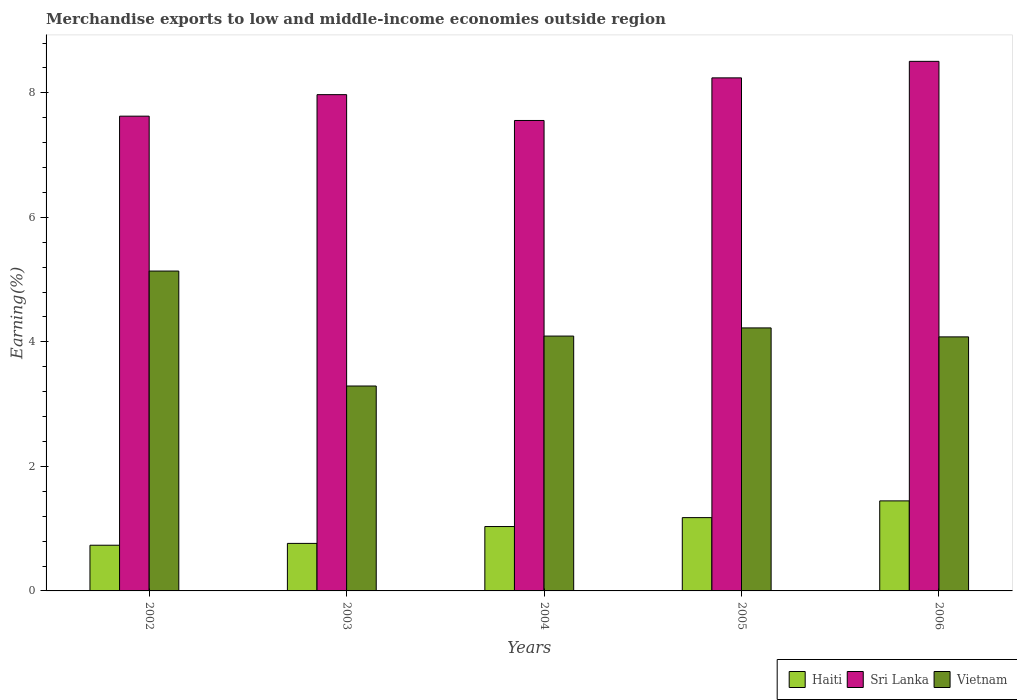Are the number of bars per tick equal to the number of legend labels?
Offer a very short reply. Yes. How many bars are there on the 1st tick from the right?
Your response must be concise. 3. In how many cases, is the number of bars for a given year not equal to the number of legend labels?
Your response must be concise. 0. What is the percentage of amount earned from merchandise exports in Sri Lanka in 2006?
Make the answer very short. 8.51. Across all years, what is the maximum percentage of amount earned from merchandise exports in Haiti?
Your answer should be very brief. 1.45. Across all years, what is the minimum percentage of amount earned from merchandise exports in Sri Lanka?
Provide a succinct answer. 7.56. In which year was the percentage of amount earned from merchandise exports in Vietnam maximum?
Make the answer very short. 2002. In which year was the percentage of amount earned from merchandise exports in Haiti minimum?
Your response must be concise. 2002. What is the total percentage of amount earned from merchandise exports in Vietnam in the graph?
Provide a short and direct response. 20.83. What is the difference between the percentage of amount earned from merchandise exports in Sri Lanka in 2002 and that in 2006?
Make the answer very short. -0.88. What is the difference between the percentage of amount earned from merchandise exports in Vietnam in 2006 and the percentage of amount earned from merchandise exports in Haiti in 2004?
Offer a terse response. 3.05. What is the average percentage of amount earned from merchandise exports in Vietnam per year?
Your answer should be very brief. 4.17. In the year 2004, what is the difference between the percentage of amount earned from merchandise exports in Vietnam and percentage of amount earned from merchandise exports in Haiti?
Your response must be concise. 3.06. In how many years, is the percentage of amount earned from merchandise exports in Vietnam greater than 8 %?
Your answer should be very brief. 0. What is the ratio of the percentage of amount earned from merchandise exports in Haiti in 2005 to that in 2006?
Your answer should be compact. 0.81. Is the percentage of amount earned from merchandise exports in Haiti in 2002 less than that in 2005?
Make the answer very short. Yes. What is the difference between the highest and the second highest percentage of amount earned from merchandise exports in Vietnam?
Ensure brevity in your answer.  0.91. What is the difference between the highest and the lowest percentage of amount earned from merchandise exports in Haiti?
Provide a short and direct response. 0.71. What does the 1st bar from the left in 2006 represents?
Provide a short and direct response. Haiti. What does the 1st bar from the right in 2003 represents?
Make the answer very short. Vietnam. Is it the case that in every year, the sum of the percentage of amount earned from merchandise exports in Vietnam and percentage of amount earned from merchandise exports in Haiti is greater than the percentage of amount earned from merchandise exports in Sri Lanka?
Ensure brevity in your answer.  No. How many years are there in the graph?
Keep it short and to the point. 5. Are the values on the major ticks of Y-axis written in scientific E-notation?
Give a very brief answer. No. Does the graph contain any zero values?
Give a very brief answer. No. Does the graph contain grids?
Offer a very short reply. No. How many legend labels are there?
Keep it short and to the point. 3. What is the title of the graph?
Your answer should be very brief. Merchandise exports to low and middle-income economies outside region. Does "Albania" appear as one of the legend labels in the graph?
Keep it short and to the point. No. What is the label or title of the Y-axis?
Your response must be concise. Earning(%). What is the Earning(%) in Haiti in 2002?
Offer a very short reply. 0.73. What is the Earning(%) of Sri Lanka in 2002?
Ensure brevity in your answer.  7.63. What is the Earning(%) of Vietnam in 2002?
Offer a terse response. 5.14. What is the Earning(%) in Haiti in 2003?
Offer a terse response. 0.76. What is the Earning(%) in Sri Lanka in 2003?
Offer a terse response. 7.97. What is the Earning(%) in Vietnam in 2003?
Provide a succinct answer. 3.29. What is the Earning(%) in Haiti in 2004?
Your answer should be very brief. 1.03. What is the Earning(%) of Sri Lanka in 2004?
Give a very brief answer. 7.56. What is the Earning(%) in Vietnam in 2004?
Ensure brevity in your answer.  4.09. What is the Earning(%) of Haiti in 2005?
Give a very brief answer. 1.18. What is the Earning(%) of Sri Lanka in 2005?
Keep it short and to the point. 8.24. What is the Earning(%) of Vietnam in 2005?
Your answer should be compact. 4.22. What is the Earning(%) of Haiti in 2006?
Ensure brevity in your answer.  1.45. What is the Earning(%) of Sri Lanka in 2006?
Your answer should be very brief. 8.51. What is the Earning(%) of Vietnam in 2006?
Offer a very short reply. 4.08. Across all years, what is the maximum Earning(%) in Haiti?
Your response must be concise. 1.45. Across all years, what is the maximum Earning(%) of Sri Lanka?
Make the answer very short. 8.51. Across all years, what is the maximum Earning(%) of Vietnam?
Make the answer very short. 5.14. Across all years, what is the minimum Earning(%) of Haiti?
Provide a short and direct response. 0.73. Across all years, what is the minimum Earning(%) in Sri Lanka?
Ensure brevity in your answer.  7.56. Across all years, what is the minimum Earning(%) of Vietnam?
Keep it short and to the point. 3.29. What is the total Earning(%) of Haiti in the graph?
Provide a short and direct response. 5.16. What is the total Earning(%) in Sri Lanka in the graph?
Provide a short and direct response. 39.9. What is the total Earning(%) of Vietnam in the graph?
Ensure brevity in your answer.  20.83. What is the difference between the Earning(%) of Haiti in 2002 and that in 2003?
Your answer should be compact. -0.03. What is the difference between the Earning(%) in Sri Lanka in 2002 and that in 2003?
Your response must be concise. -0.35. What is the difference between the Earning(%) of Vietnam in 2002 and that in 2003?
Keep it short and to the point. 1.85. What is the difference between the Earning(%) in Haiti in 2002 and that in 2004?
Offer a very short reply. -0.3. What is the difference between the Earning(%) in Sri Lanka in 2002 and that in 2004?
Keep it short and to the point. 0.07. What is the difference between the Earning(%) of Vietnam in 2002 and that in 2004?
Your answer should be compact. 1.04. What is the difference between the Earning(%) in Haiti in 2002 and that in 2005?
Provide a short and direct response. -0.44. What is the difference between the Earning(%) in Sri Lanka in 2002 and that in 2005?
Your answer should be very brief. -0.62. What is the difference between the Earning(%) of Vietnam in 2002 and that in 2005?
Your answer should be very brief. 0.91. What is the difference between the Earning(%) of Haiti in 2002 and that in 2006?
Offer a terse response. -0.71. What is the difference between the Earning(%) of Sri Lanka in 2002 and that in 2006?
Provide a short and direct response. -0.88. What is the difference between the Earning(%) of Vietnam in 2002 and that in 2006?
Provide a succinct answer. 1.06. What is the difference between the Earning(%) in Haiti in 2003 and that in 2004?
Keep it short and to the point. -0.27. What is the difference between the Earning(%) of Sri Lanka in 2003 and that in 2004?
Provide a succinct answer. 0.41. What is the difference between the Earning(%) of Vietnam in 2003 and that in 2004?
Provide a succinct answer. -0.8. What is the difference between the Earning(%) in Haiti in 2003 and that in 2005?
Keep it short and to the point. -0.41. What is the difference between the Earning(%) of Sri Lanka in 2003 and that in 2005?
Your answer should be very brief. -0.27. What is the difference between the Earning(%) of Vietnam in 2003 and that in 2005?
Keep it short and to the point. -0.93. What is the difference between the Earning(%) of Haiti in 2003 and that in 2006?
Keep it short and to the point. -0.68. What is the difference between the Earning(%) in Sri Lanka in 2003 and that in 2006?
Keep it short and to the point. -0.53. What is the difference between the Earning(%) in Vietnam in 2003 and that in 2006?
Offer a very short reply. -0.79. What is the difference between the Earning(%) in Haiti in 2004 and that in 2005?
Provide a short and direct response. -0.14. What is the difference between the Earning(%) in Sri Lanka in 2004 and that in 2005?
Your response must be concise. -0.68. What is the difference between the Earning(%) of Vietnam in 2004 and that in 2005?
Keep it short and to the point. -0.13. What is the difference between the Earning(%) of Haiti in 2004 and that in 2006?
Your answer should be compact. -0.41. What is the difference between the Earning(%) of Sri Lanka in 2004 and that in 2006?
Your response must be concise. -0.95. What is the difference between the Earning(%) of Vietnam in 2004 and that in 2006?
Provide a short and direct response. 0.01. What is the difference between the Earning(%) of Haiti in 2005 and that in 2006?
Your answer should be compact. -0.27. What is the difference between the Earning(%) in Sri Lanka in 2005 and that in 2006?
Keep it short and to the point. -0.27. What is the difference between the Earning(%) of Vietnam in 2005 and that in 2006?
Provide a short and direct response. 0.14. What is the difference between the Earning(%) in Haiti in 2002 and the Earning(%) in Sri Lanka in 2003?
Your response must be concise. -7.24. What is the difference between the Earning(%) of Haiti in 2002 and the Earning(%) of Vietnam in 2003?
Give a very brief answer. -2.56. What is the difference between the Earning(%) in Sri Lanka in 2002 and the Earning(%) in Vietnam in 2003?
Your answer should be very brief. 4.33. What is the difference between the Earning(%) of Haiti in 2002 and the Earning(%) of Sri Lanka in 2004?
Your response must be concise. -6.82. What is the difference between the Earning(%) of Haiti in 2002 and the Earning(%) of Vietnam in 2004?
Offer a very short reply. -3.36. What is the difference between the Earning(%) in Sri Lanka in 2002 and the Earning(%) in Vietnam in 2004?
Make the answer very short. 3.53. What is the difference between the Earning(%) in Haiti in 2002 and the Earning(%) in Sri Lanka in 2005?
Your response must be concise. -7.51. What is the difference between the Earning(%) of Haiti in 2002 and the Earning(%) of Vietnam in 2005?
Offer a terse response. -3.49. What is the difference between the Earning(%) in Sri Lanka in 2002 and the Earning(%) in Vietnam in 2005?
Provide a succinct answer. 3.4. What is the difference between the Earning(%) of Haiti in 2002 and the Earning(%) of Sri Lanka in 2006?
Offer a terse response. -7.77. What is the difference between the Earning(%) of Haiti in 2002 and the Earning(%) of Vietnam in 2006?
Your answer should be very brief. -3.35. What is the difference between the Earning(%) in Sri Lanka in 2002 and the Earning(%) in Vietnam in 2006?
Keep it short and to the point. 3.55. What is the difference between the Earning(%) in Haiti in 2003 and the Earning(%) in Sri Lanka in 2004?
Your answer should be very brief. -6.79. What is the difference between the Earning(%) in Haiti in 2003 and the Earning(%) in Vietnam in 2004?
Your response must be concise. -3.33. What is the difference between the Earning(%) of Sri Lanka in 2003 and the Earning(%) of Vietnam in 2004?
Give a very brief answer. 3.88. What is the difference between the Earning(%) in Haiti in 2003 and the Earning(%) in Sri Lanka in 2005?
Keep it short and to the point. -7.48. What is the difference between the Earning(%) in Haiti in 2003 and the Earning(%) in Vietnam in 2005?
Make the answer very short. -3.46. What is the difference between the Earning(%) of Sri Lanka in 2003 and the Earning(%) of Vietnam in 2005?
Your answer should be very brief. 3.75. What is the difference between the Earning(%) of Haiti in 2003 and the Earning(%) of Sri Lanka in 2006?
Offer a terse response. -7.74. What is the difference between the Earning(%) in Haiti in 2003 and the Earning(%) in Vietnam in 2006?
Provide a succinct answer. -3.32. What is the difference between the Earning(%) in Sri Lanka in 2003 and the Earning(%) in Vietnam in 2006?
Give a very brief answer. 3.89. What is the difference between the Earning(%) in Haiti in 2004 and the Earning(%) in Sri Lanka in 2005?
Give a very brief answer. -7.21. What is the difference between the Earning(%) of Haiti in 2004 and the Earning(%) of Vietnam in 2005?
Offer a very short reply. -3.19. What is the difference between the Earning(%) of Sri Lanka in 2004 and the Earning(%) of Vietnam in 2005?
Offer a terse response. 3.33. What is the difference between the Earning(%) of Haiti in 2004 and the Earning(%) of Sri Lanka in 2006?
Provide a short and direct response. -7.47. What is the difference between the Earning(%) of Haiti in 2004 and the Earning(%) of Vietnam in 2006?
Offer a terse response. -3.05. What is the difference between the Earning(%) in Sri Lanka in 2004 and the Earning(%) in Vietnam in 2006?
Give a very brief answer. 3.48. What is the difference between the Earning(%) in Haiti in 2005 and the Earning(%) in Sri Lanka in 2006?
Provide a short and direct response. -7.33. What is the difference between the Earning(%) of Haiti in 2005 and the Earning(%) of Vietnam in 2006?
Your answer should be very brief. -2.9. What is the difference between the Earning(%) of Sri Lanka in 2005 and the Earning(%) of Vietnam in 2006?
Provide a succinct answer. 4.16. What is the average Earning(%) in Haiti per year?
Offer a very short reply. 1.03. What is the average Earning(%) of Sri Lanka per year?
Provide a succinct answer. 7.98. What is the average Earning(%) in Vietnam per year?
Your answer should be compact. 4.17. In the year 2002, what is the difference between the Earning(%) in Haiti and Earning(%) in Sri Lanka?
Provide a short and direct response. -6.89. In the year 2002, what is the difference between the Earning(%) in Haiti and Earning(%) in Vietnam?
Offer a terse response. -4.4. In the year 2002, what is the difference between the Earning(%) of Sri Lanka and Earning(%) of Vietnam?
Give a very brief answer. 2.49. In the year 2003, what is the difference between the Earning(%) in Haiti and Earning(%) in Sri Lanka?
Provide a short and direct response. -7.21. In the year 2003, what is the difference between the Earning(%) of Haiti and Earning(%) of Vietnam?
Your answer should be very brief. -2.53. In the year 2003, what is the difference between the Earning(%) in Sri Lanka and Earning(%) in Vietnam?
Make the answer very short. 4.68. In the year 2004, what is the difference between the Earning(%) in Haiti and Earning(%) in Sri Lanka?
Ensure brevity in your answer.  -6.52. In the year 2004, what is the difference between the Earning(%) in Haiti and Earning(%) in Vietnam?
Keep it short and to the point. -3.06. In the year 2004, what is the difference between the Earning(%) of Sri Lanka and Earning(%) of Vietnam?
Offer a terse response. 3.46. In the year 2005, what is the difference between the Earning(%) of Haiti and Earning(%) of Sri Lanka?
Give a very brief answer. -7.06. In the year 2005, what is the difference between the Earning(%) in Haiti and Earning(%) in Vietnam?
Offer a terse response. -3.05. In the year 2005, what is the difference between the Earning(%) in Sri Lanka and Earning(%) in Vietnam?
Make the answer very short. 4.02. In the year 2006, what is the difference between the Earning(%) of Haiti and Earning(%) of Sri Lanka?
Keep it short and to the point. -7.06. In the year 2006, what is the difference between the Earning(%) in Haiti and Earning(%) in Vietnam?
Your answer should be compact. -2.63. In the year 2006, what is the difference between the Earning(%) in Sri Lanka and Earning(%) in Vietnam?
Make the answer very short. 4.43. What is the ratio of the Earning(%) in Haiti in 2002 to that in 2003?
Your answer should be compact. 0.96. What is the ratio of the Earning(%) in Sri Lanka in 2002 to that in 2003?
Offer a terse response. 0.96. What is the ratio of the Earning(%) of Vietnam in 2002 to that in 2003?
Provide a succinct answer. 1.56. What is the ratio of the Earning(%) of Haiti in 2002 to that in 2004?
Keep it short and to the point. 0.71. What is the ratio of the Earning(%) of Sri Lanka in 2002 to that in 2004?
Your answer should be very brief. 1.01. What is the ratio of the Earning(%) of Vietnam in 2002 to that in 2004?
Offer a very short reply. 1.26. What is the ratio of the Earning(%) of Haiti in 2002 to that in 2005?
Give a very brief answer. 0.62. What is the ratio of the Earning(%) in Sri Lanka in 2002 to that in 2005?
Your answer should be very brief. 0.93. What is the ratio of the Earning(%) in Vietnam in 2002 to that in 2005?
Your answer should be very brief. 1.22. What is the ratio of the Earning(%) in Haiti in 2002 to that in 2006?
Ensure brevity in your answer.  0.51. What is the ratio of the Earning(%) of Sri Lanka in 2002 to that in 2006?
Provide a succinct answer. 0.9. What is the ratio of the Earning(%) of Vietnam in 2002 to that in 2006?
Make the answer very short. 1.26. What is the ratio of the Earning(%) in Haiti in 2003 to that in 2004?
Give a very brief answer. 0.74. What is the ratio of the Earning(%) of Sri Lanka in 2003 to that in 2004?
Your answer should be very brief. 1.05. What is the ratio of the Earning(%) of Vietnam in 2003 to that in 2004?
Offer a very short reply. 0.8. What is the ratio of the Earning(%) of Haiti in 2003 to that in 2005?
Make the answer very short. 0.65. What is the ratio of the Earning(%) of Sri Lanka in 2003 to that in 2005?
Your response must be concise. 0.97. What is the ratio of the Earning(%) in Vietnam in 2003 to that in 2005?
Provide a short and direct response. 0.78. What is the ratio of the Earning(%) of Haiti in 2003 to that in 2006?
Your answer should be compact. 0.53. What is the ratio of the Earning(%) of Sri Lanka in 2003 to that in 2006?
Provide a succinct answer. 0.94. What is the ratio of the Earning(%) in Vietnam in 2003 to that in 2006?
Give a very brief answer. 0.81. What is the ratio of the Earning(%) of Haiti in 2004 to that in 2005?
Keep it short and to the point. 0.88. What is the ratio of the Earning(%) in Sri Lanka in 2004 to that in 2005?
Keep it short and to the point. 0.92. What is the ratio of the Earning(%) in Haiti in 2004 to that in 2006?
Give a very brief answer. 0.72. What is the ratio of the Earning(%) in Sri Lanka in 2004 to that in 2006?
Give a very brief answer. 0.89. What is the ratio of the Earning(%) in Haiti in 2005 to that in 2006?
Provide a short and direct response. 0.81. What is the ratio of the Earning(%) of Sri Lanka in 2005 to that in 2006?
Offer a very short reply. 0.97. What is the ratio of the Earning(%) in Vietnam in 2005 to that in 2006?
Provide a succinct answer. 1.04. What is the difference between the highest and the second highest Earning(%) in Haiti?
Offer a very short reply. 0.27. What is the difference between the highest and the second highest Earning(%) in Sri Lanka?
Provide a succinct answer. 0.27. What is the difference between the highest and the second highest Earning(%) of Vietnam?
Offer a very short reply. 0.91. What is the difference between the highest and the lowest Earning(%) in Haiti?
Your answer should be compact. 0.71. What is the difference between the highest and the lowest Earning(%) in Sri Lanka?
Your answer should be compact. 0.95. What is the difference between the highest and the lowest Earning(%) of Vietnam?
Give a very brief answer. 1.85. 